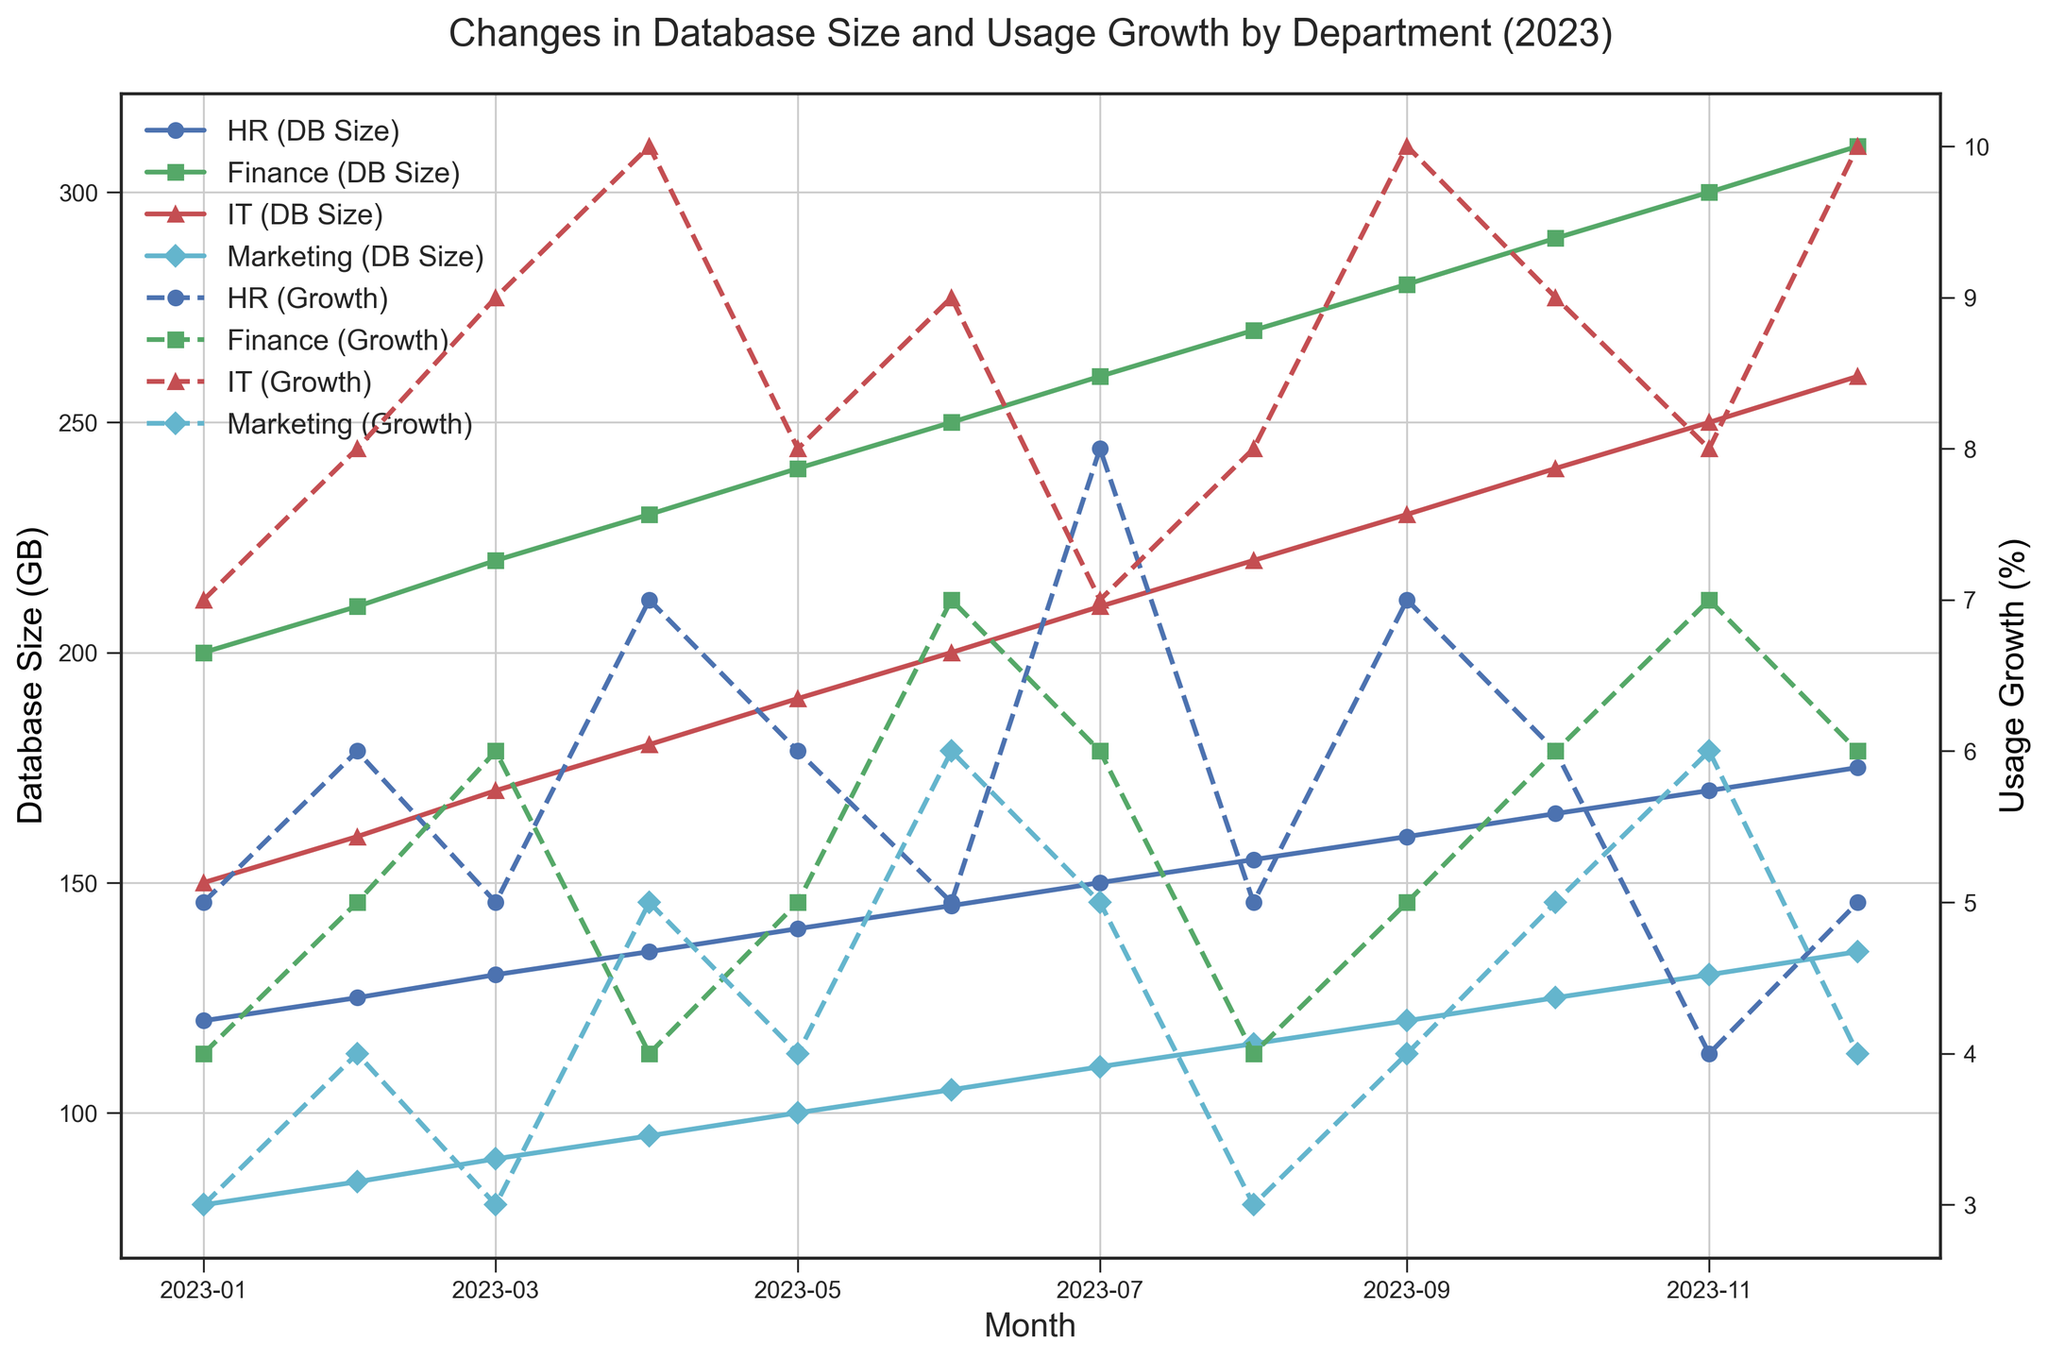What is the peak database size for the Finance department and in which month does it occur? The highest data point for the Finance department in terms of database size can be seen at the end of the line representing the Finance department. The peak size is 310 GB in December.
Answer: 310 GB, December Which department experienced the highest usage growth percentage in September? By looking at the dashed lines representing usage growth percentages for each department in September, the IT department has the highest data point at 10%.
Answer: IT, 10% Between January and June, which department shows the most significant increase in database size and what is the difference in GB? Calculate the difference in size from January to June for each department: HR (145-120=25), Finance (250-200=50), IT (200-150=50), Marketing (105-80=25). Both Finance and IT have the most significant increase of 50 GB.
Answer: Finance and IT, 50 GB Which department has the lowest overall usage growth percentage fluctuation throughout the year? Compare the difference between the highest and lowest points for the dashed lines representing all departments. The HR department's growth varies between 4% and 8%, which is a range of 4%, lower compared to other departments.
Answer: HR, 4% In which month does the Marketing department reach a database size of 100 GB, and what is the corresponding usage growth percentage? Find the data point where the solid line representing the Marketing department crosses 100 GB. It happens in May, with a corresponding growth percentage shown by the dashed line at 4%.
Answer: May, 4% What is the average usage growth percentage for the IT department throughout the year? Add all the monthly usage growth percentages for the IT department (7+8+9+10+8+9+7+8+10+9+8+10) = 103. Divide this sum by 12 (number of months) to get the average.
Answer: 8.58% Which month has the largest difference in usage growth percentage between the Finance and IT departments, and what is the difference? Calculate the monthly differences for each month between the Finance and IT lines.
 Jan: 7-4=3, Feb: 8-5=3, Mar: 9-6=3, Apr: 10-4=6, May: 8-5=3, Jun: 9-7=2, Jul: 7-6=1, Aug: 8-4=4, Sep: 10-5=5, Oct: 9-6=3, Nov: 8-7=1, Dec: 10-6=4. The largest difference is in April at 6%.
Answer: April, 6% In which month did HR experience the smallest usage growth percentage, and what was the database size that month? Check the data points for HR's usage growth. The smallest is 4% in November, with a corresponding solid line indicating a database size of 170 GB.
Answer: November, 170 GB What is the total change in database size for the Marketing department from January to December? Calculate the difference in database size for Marketing from January (80 GB) to December (135 GB): 135-80 = 55 GB.
Answer: 55 GB Which department had a larger increase in database size in the first quarter of the year, IT or Marketing, and by how much? Calculate the increase from January to March for both departments: IT (170-150=20), Marketing (90-80=10). IT had a larger increase by 10 GB compared to Marketing.
Answer: IT, 10 GB 